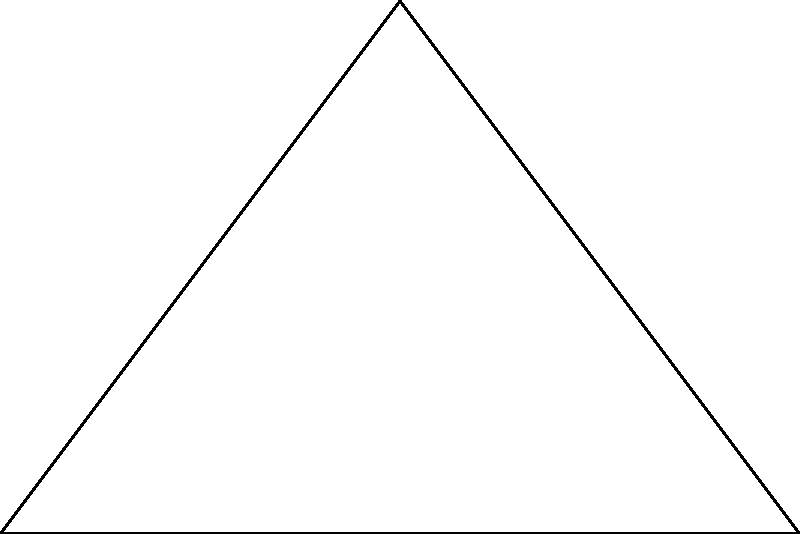You're designing a triangular paddock for practicing horse yoga exercises. The paddock has a right angle at point C, with AC = 4 meters and BC = 6 meters. Calculate the area of this triangular paddock in square meters. To find the area of the triangular paddock, we can use the formula for the area of a right triangle:

Area = $\frac{1}{2} \times base \times height$

Given:
- AC (height) = 4 meters
- BC (base) = 6 meters

Step 1: Substitute the values into the formula
Area = $\frac{1}{2} \times 6 \times 4$

Step 2: Multiply
Area = $\frac{1}{2} \times 24 = 12$

Therefore, the area of the triangular paddock is 12 square meters.
Answer: 12 m² 